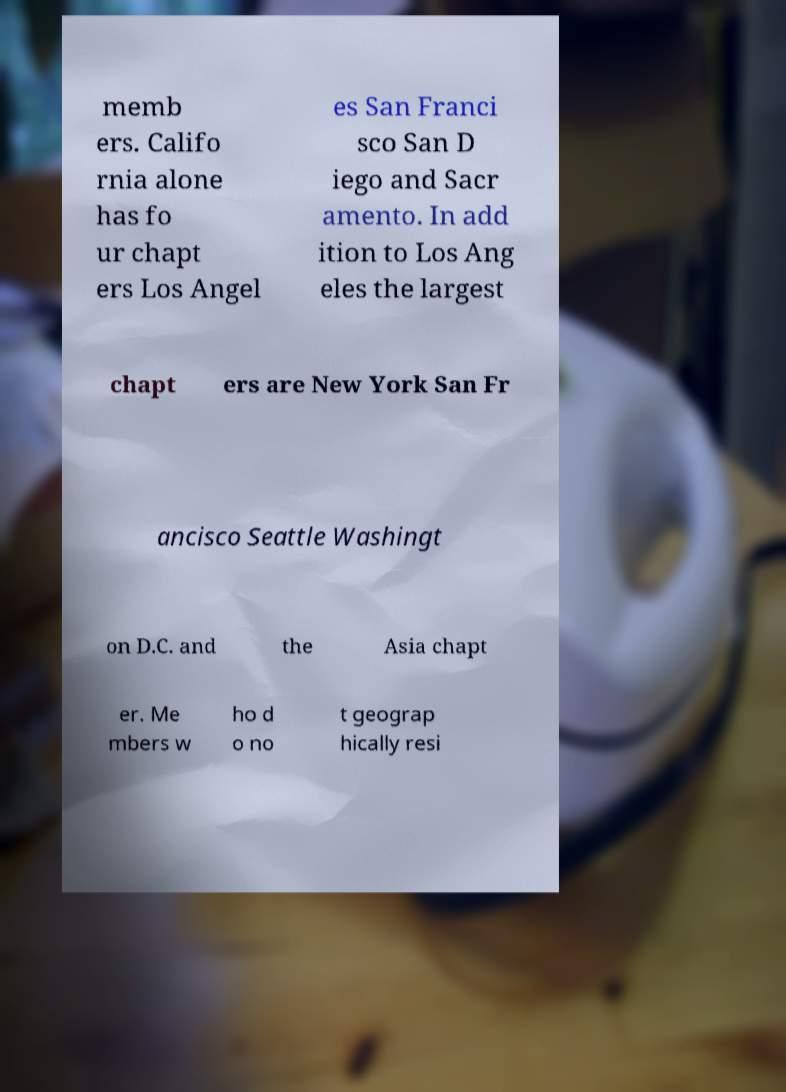What messages or text are displayed in this image? I need them in a readable, typed format. memb ers. Califo rnia alone has fo ur chapt ers Los Angel es San Franci sco San D iego and Sacr amento. In add ition to Los Ang eles the largest chapt ers are New York San Fr ancisco Seattle Washingt on D.C. and the Asia chapt er. Me mbers w ho d o no t geograp hically resi 